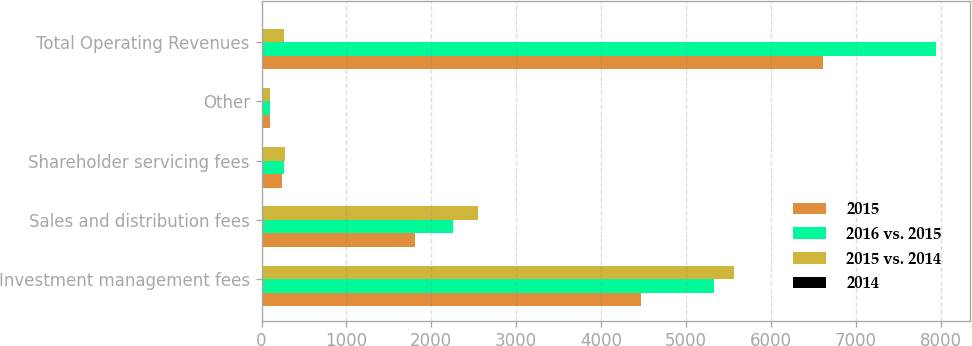Convert chart. <chart><loc_0><loc_0><loc_500><loc_500><stacked_bar_chart><ecel><fcel>Investment management fees<fcel>Sales and distribution fees<fcel>Shareholder servicing fees<fcel>Other<fcel>Total Operating Revenues<nl><fcel>2015<fcel>4471.7<fcel>1806.4<fcel>243.6<fcel>96.3<fcel>6618<nl><fcel>2016 vs. 2015<fcel>5327.8<fcel>2252.4<fcel>262.8<fcel>105.7<fcel>7948.7<nl><fcel>2015 vs. 2014<fcel>5565.7<fcel>2546.4<fcel>281.1<fcel>98.2<fcel>262.8<nl><fcel>2014<fcel>16<fcel>20<fcel>7<fcel>9<fcel>17<nl></chart> 